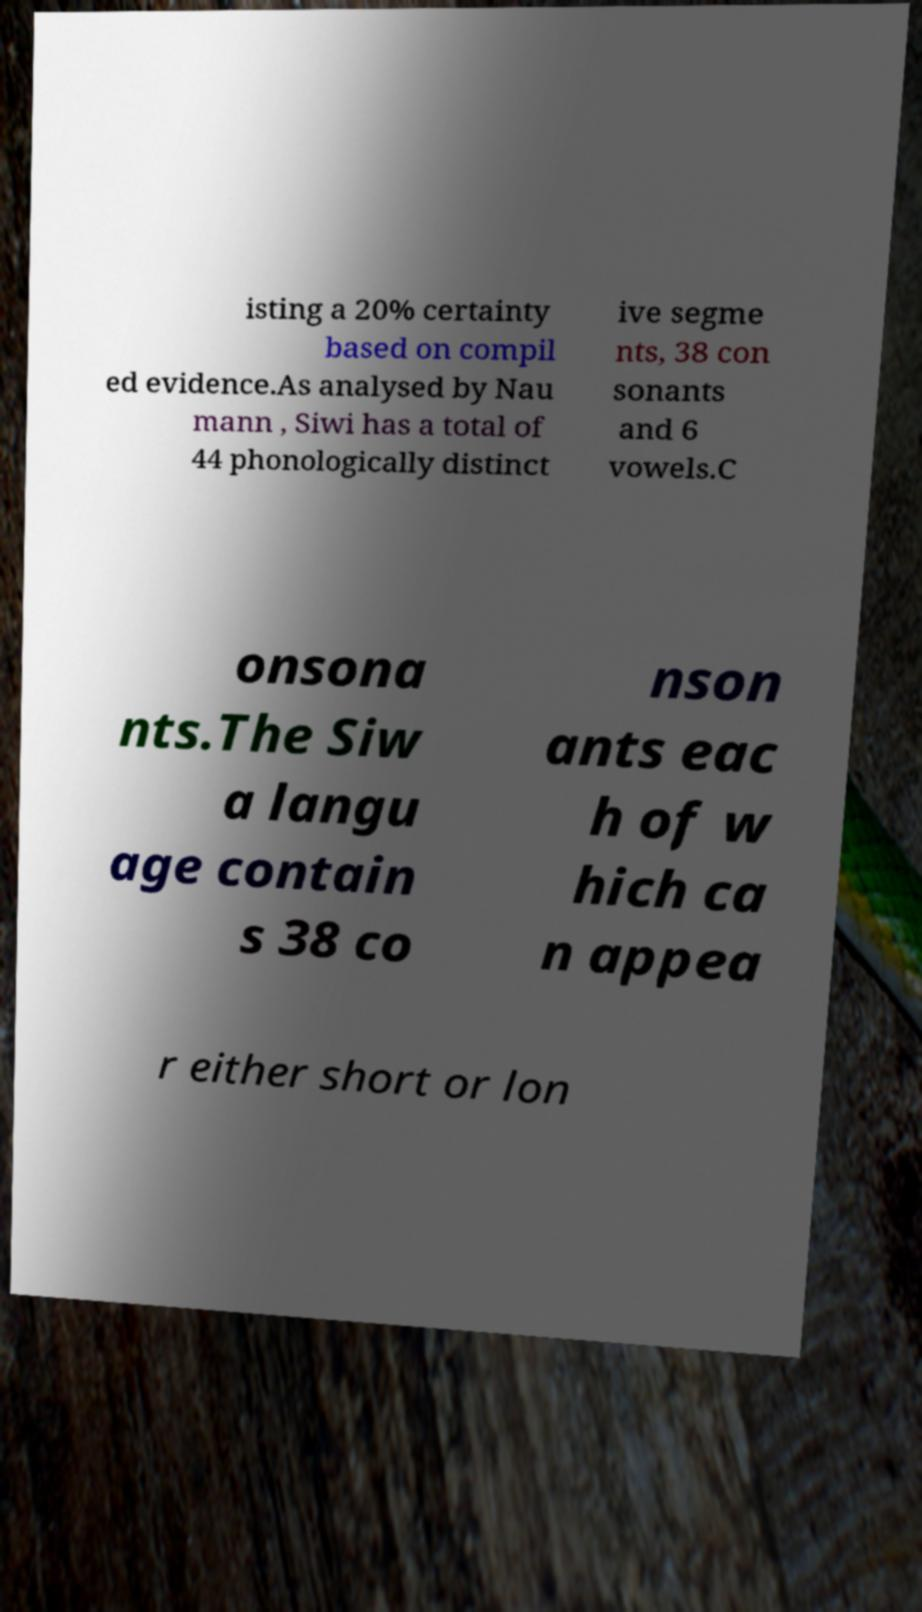Can you accurately transcribe the text from the provided image for me? isting a 20% certainty based on compil ed evidence.As analysed by Nau mann , Siwi has a total of 44 phonologically distinct ive segme nts, 38 con sonants and 6 vowels.C onsona nts.The Siw a langu age contain s 38 co nson ants eac h of w hich ca n appea r either short or lon 